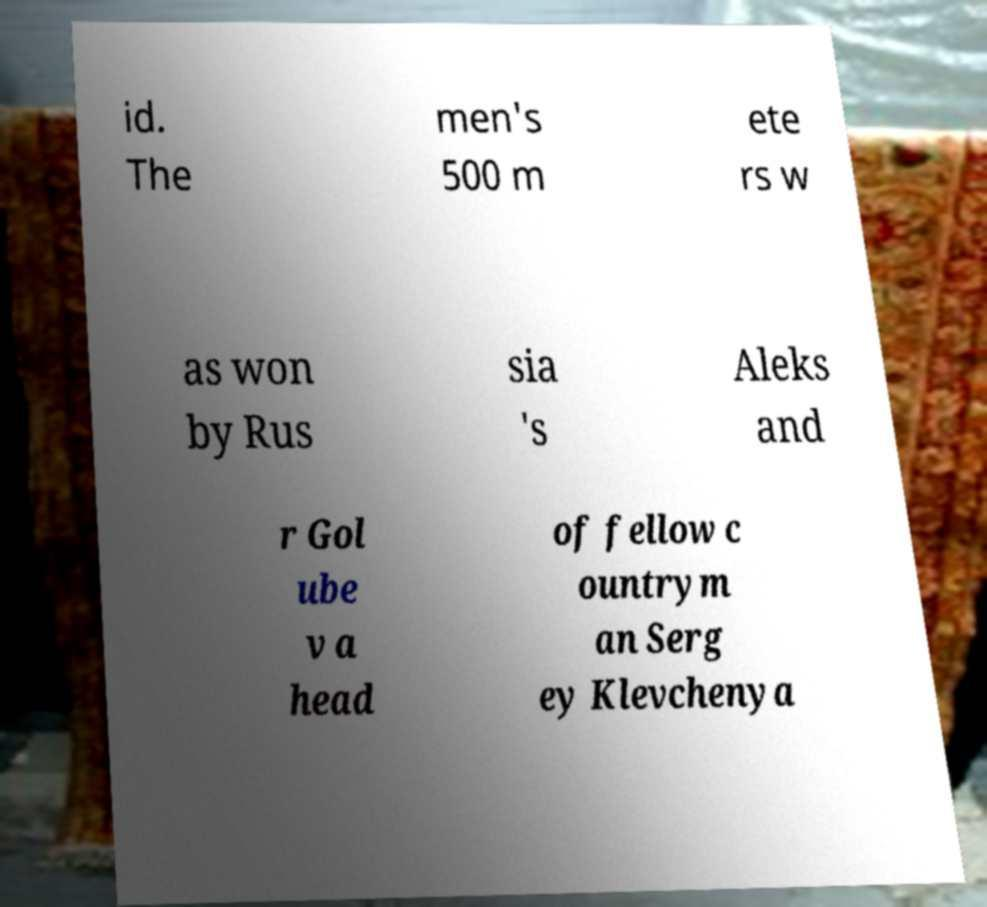I need the written content from this picture converted into text. Can you do that? id. The men's 500 m ete rs w as won by Rus sia 's Aleks and r Gol ube v a head of fellow c ountrym an Serg ey Klevchenya 